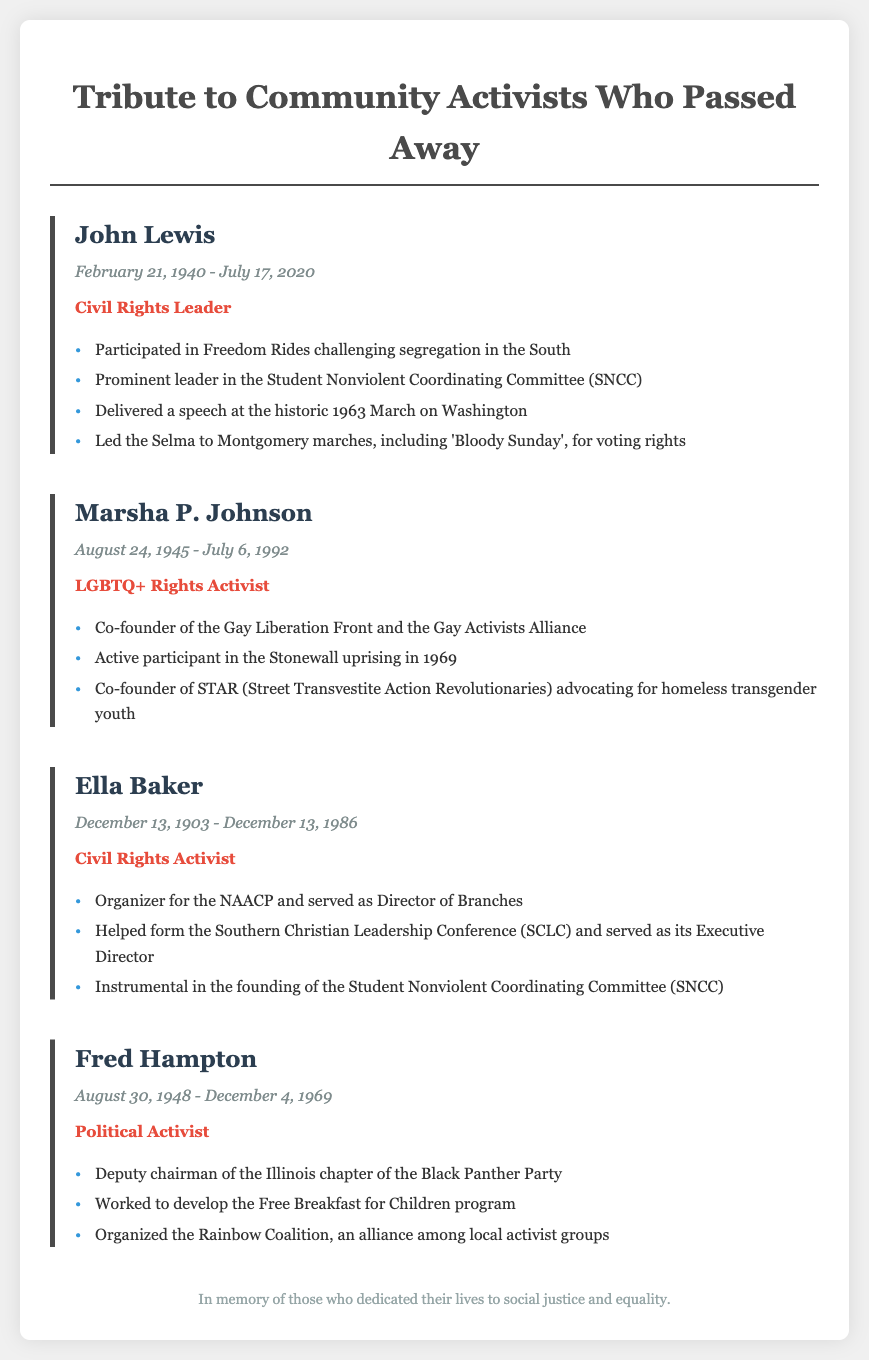what is the title of the document? The title of the document is prominently displayed at the top, indicating it’s a tribute to community activists.
Answer: Tribute to Community Activists Who Passed Away who was a Civil Rights Leader mentioned in the document? The document lists John Lewis as one of the community activists and specifies his role as a Civil Rights Leader.
Answer: John Lewis when did Ella Baker pass away? The death date of Ella Baker is clearly stated in the document for this creator.
Answer: December 13, 1986 what major event did Marsha P. Johnson participate in? The document highlights Marsha P. Johnson's involvement in a significant historical event related to LGBTQ+ rights.
Answer: Stonewall uprising who organized the Free Breakfast for Children program? The document identifies a specific activist associated with this community support initiative.
Answer: Fred Hampton how many activists are mentioned in the document? The document includes a specific number of community activists highlighted to pay tribute.
Answer: Four which activist was involved in SNCC? The document mentions the organization SNCC in relation to certain activists, identifying one prominently associated with it.
Answer: John Lewis what year was John Lewis born? The birth year of John Lewis is stated in the document under his dates of life.
Answer: 1940 